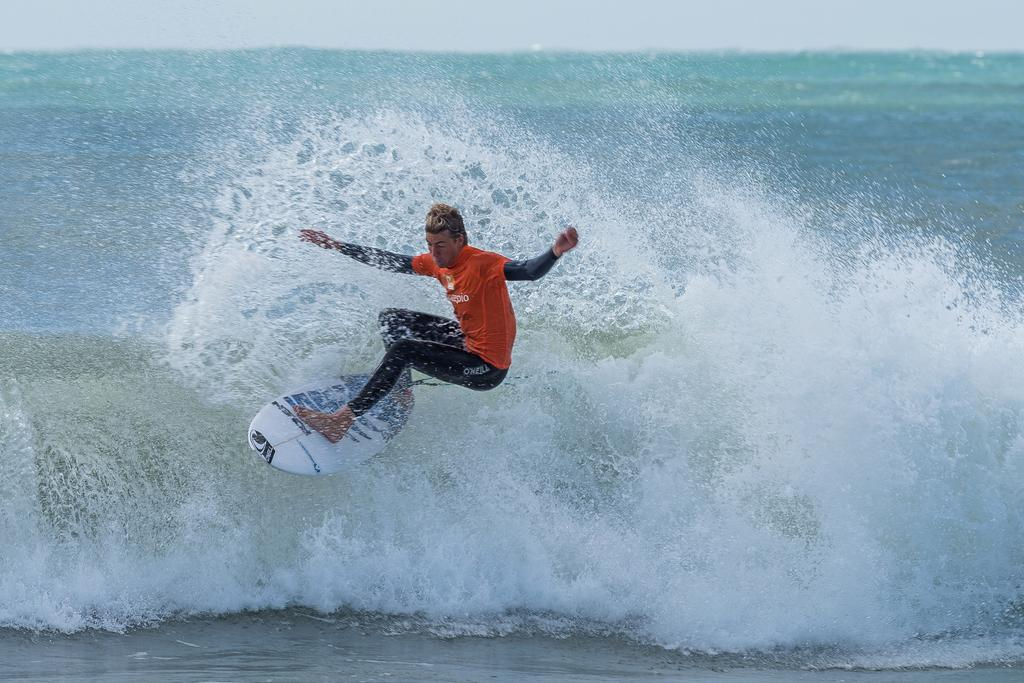<image>
Present a compact description of the photo's key features. A man wearing an O'Neil wetsuit is surfing a wave on an O'Neil board. 